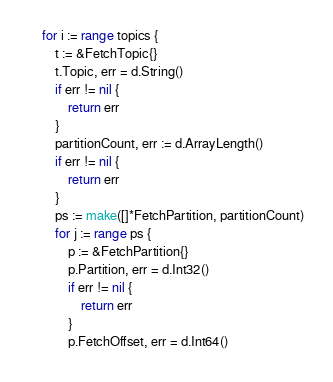<code> <loc_0><loc_0><loc_500><loc_500><_Go_>	for i := range topics {
		t := &FetchTopic{}
		t.Topic, err = d.String()
		if err != nil {
			return err
		}
		partitionCount, err := d.ArrayLength()
		if err != nil {
			return err
		}
		ps := make([]*FetchPartition, partitionCount)
		for j := range ps {
			p := &FetchPartition{}
			p.Partition, err = d.Int32()
			if err != nil {
				return err
			}
			p.FetchOffset, err = d.Int64()</code> 